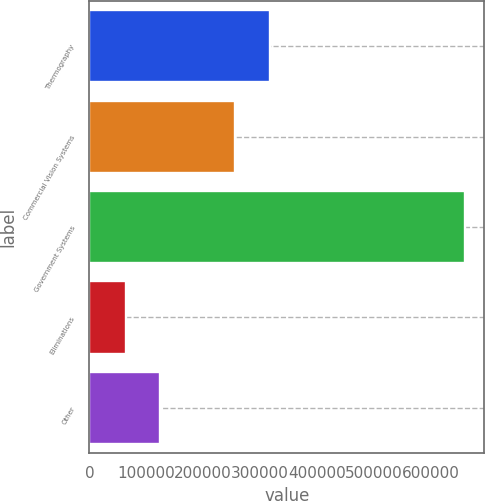Convert chart to OTSL. <chart><loc_0><loc_0><loc_500><loc_500><bar_chart><fcel>Thermography<fcel>Commercial Vision Systems<fcel>Government Systems<fcel>Eliminations<fcel>Other<nl><fcel>317936<fcel>256102<fcel>661072<fcel>64271<fcel>123951<nl></chart> 